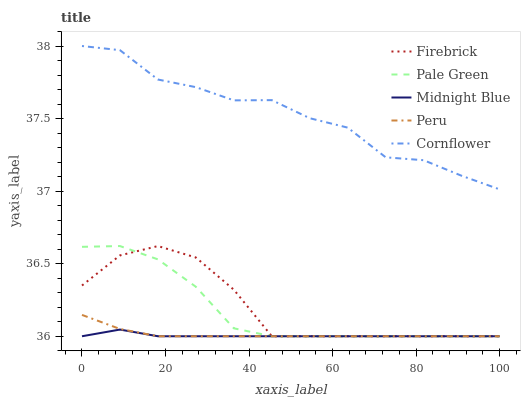Does Midnight Blue have the minimum area under the curve?
Answer yes or no. Yes. Does Cornflower have the maximum area under the curve?
Answer yes or no. Yes. Does Firebrick have the minimum area under the curve?
Answer yes or no. No. Does Firebrick have the maximum area under the curve?
Answer yes or no. No. Is Peru the smoothest?
Answer yes or no. Yes. Is Cornflower the roughest?
Answer yes or no. Yes. Is Firebrick the smoothest?
Answer yes or no. No. Is Firebrick the roughest?
Answer yes or no. No. Does Firebrick have the lowest value?
Answer yes or no. Yes. Does Cornflower have the highest value?
Answer yes or no. Yes. Does Firebrick have the highest value?
Answer yes or no. No. Is Firebrick less than Cornflower?
Answer yes or no. Yes. Is Cornflower greater than Firebrick?
Answer yes or no. Yes. Does Midnight Blue intersect Firebrick?
Answer yes or no. Yes. Is Midnight Blue less than Firebrick?
Answer yes or no. No. Is Midnight Blue greater than Firebrick?
Answer yes or no. No. Does Firebrick intersect Cornflower?
Answer yes or no. No. 